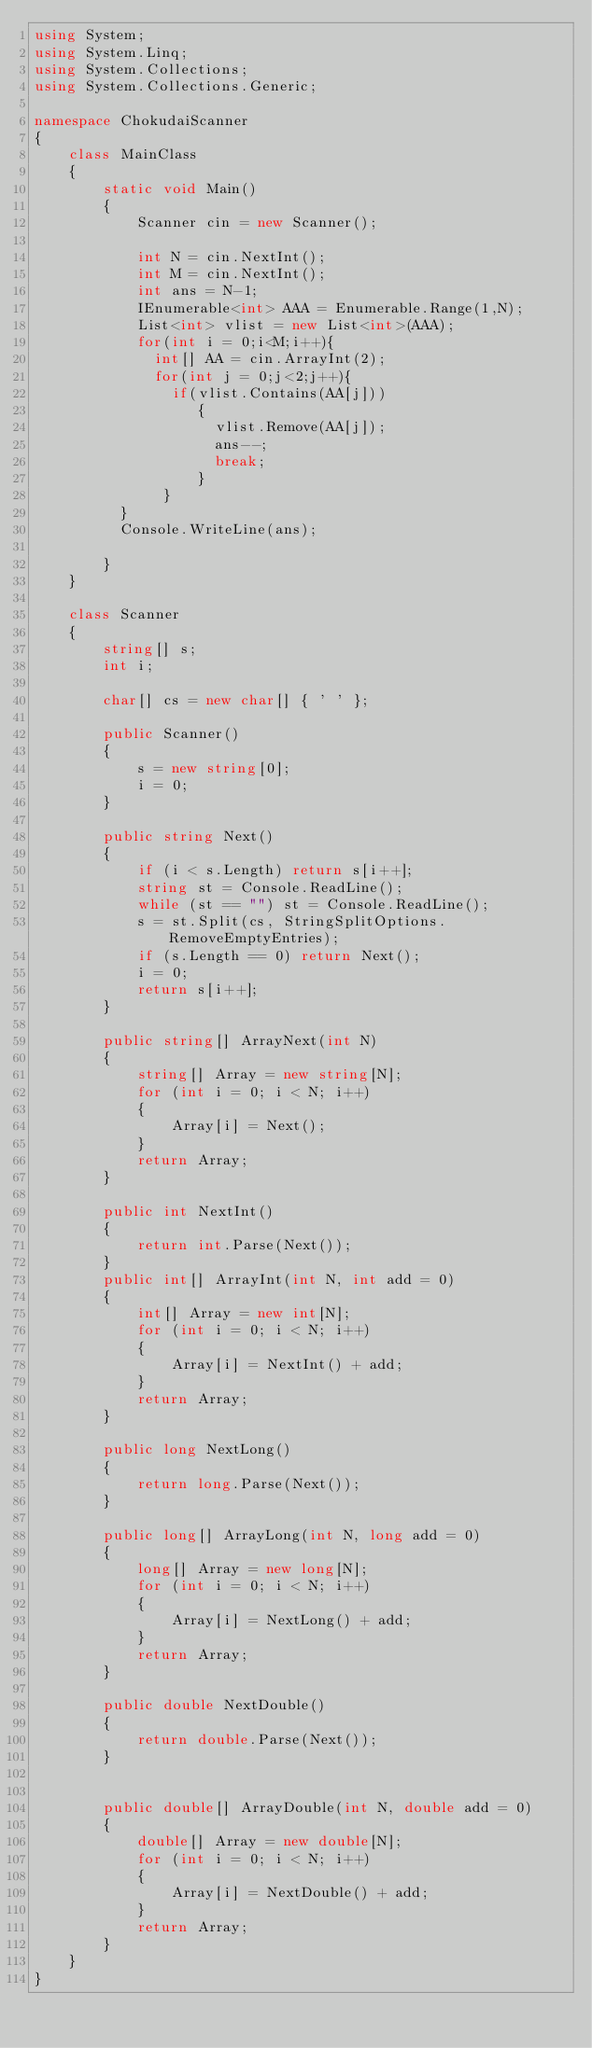<code> <loc_0><loc_0><loc_500><loc_500><_C#_>using System;
using System.Linq;
using System.Collections;
using System.Collections.Generic;

namespace ChokudaiScanner
{
    class MainClass
    {
        static void Main()
        {
            Scanner cin = new Scanner();

            int N = cin.NextInt();
          	int M = cin.NextInt();
          	int ans = N-1;
          	IEnumerable<int> AAA = Enumerable.Range(1,N);
          	List<int> vlist = new List<int>(AAA);
          	for(int i = 0;i<M;i++){
              int[] AA = cin.ArrayInt(2);
              for(int j = 0;j<2;j++){
                if(vlist.Contains(AA[j]))
                   {
                     vlist.Remove(AA[j]);
                     ans--;
                     break;
                   }
               }
       	  }
          Console.WriteLine(ans);
                
        }
    }

    class Scanner
    {
        string[] s;
        int i;

        char[] cs = new char[] { ' ' };

        public Scanner()
        {
            s = new string[0];
            i = 0;
        }

        public string Next()
        {
            if (i < s.Length) return s[i++];
            string st = Console.ReadLine();
            while (st == "") st = Console.ReadLine();
            s = st.Split(cs, StringSplitOptions.RemoveEmptyEntries);
            if (s.Length == 0) return Next();
            i = 0;
            return s[i++];
        }

        public string[] ArrayNext(int N)
        {
            string[] Array = new string[N];
            for (int i = 0; i < N; i++)
            {
                Array[i] = Next();
            }
            return Array;
        }

        public int NextInt()
        {
            return int.Parse(Next());
        }
        public int[] ArrayInt(int N, int add = 0)
        {
            int[] Array = new int[N];
            for (int i = 0; i < N; i++)
            {
                Array[i] = NextInt() + add;
            }
            return Array;
        }

        public long NextLong()
        {
            return long.Parse(Next());
        }

        public long[] ArrayLong(int N, long add = 0)
        {
            long[] Array = new long[N];
            for (int i = 0; i < N; i++)
            {
                Array[i] = NextLong() + add;
            }
            return Array;
        }

        public double NextDouble()
        {
            return double.Parse(Next());
        }


        public double[] ArrayDouble(int N, double add = 0)
        {
            double[] Array = new double[N];
            for (int i = 0; i < N; i++)
            {
                Array[i] = NextDouble() + add;
            }
            return Array;
        }
    }
}

</code> 